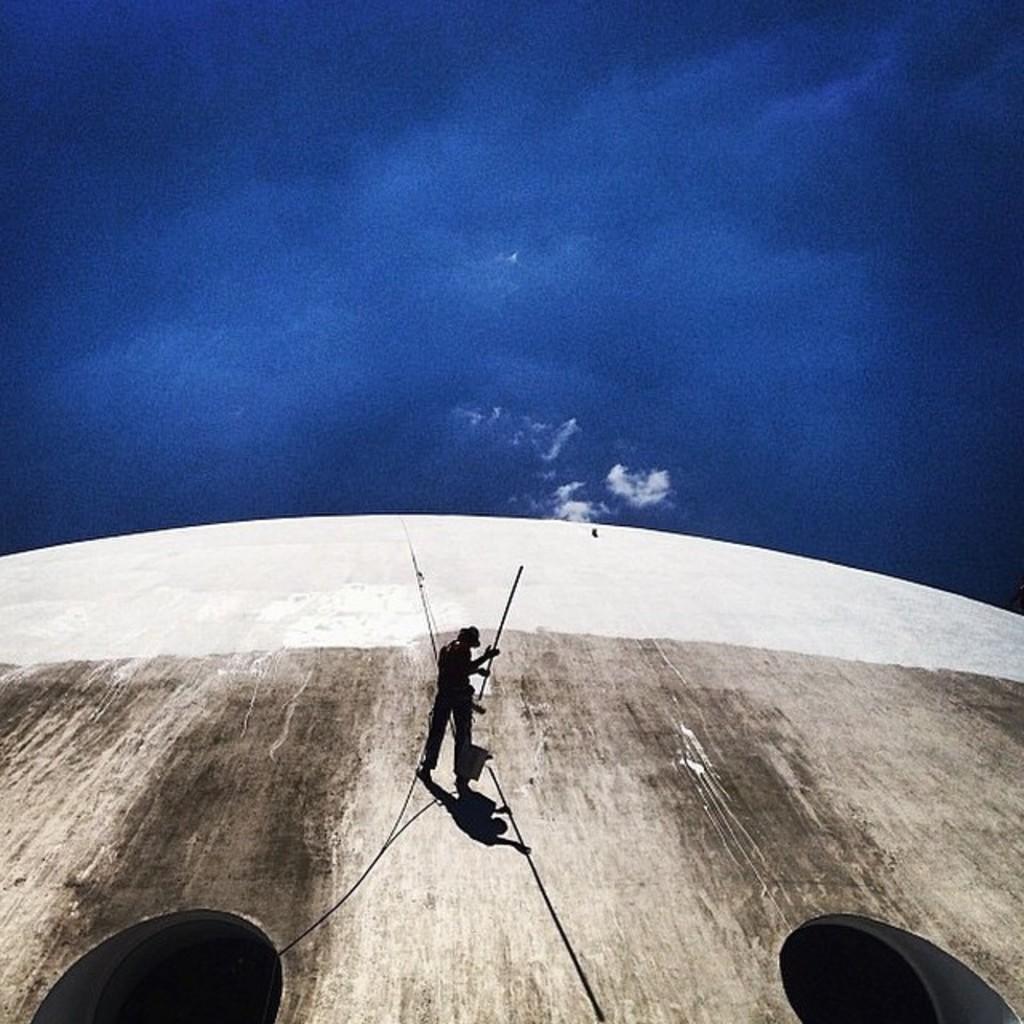Can you describe this image briefly? There is one man present on the wall and holding a stick as we can see at the bottom of this image. The sky is in the background. We can see two holes at the bottom of this image. 